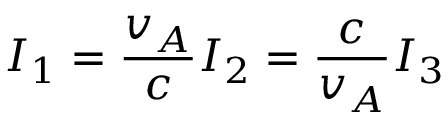<formula> <loc_0><loc_0><loc_500><loc_500>I _ { 1 } = \frac { v _ { A } } { c } I _ { 2 } = \frac { c } { v _ { A } } I _ { 3 }</formula> 